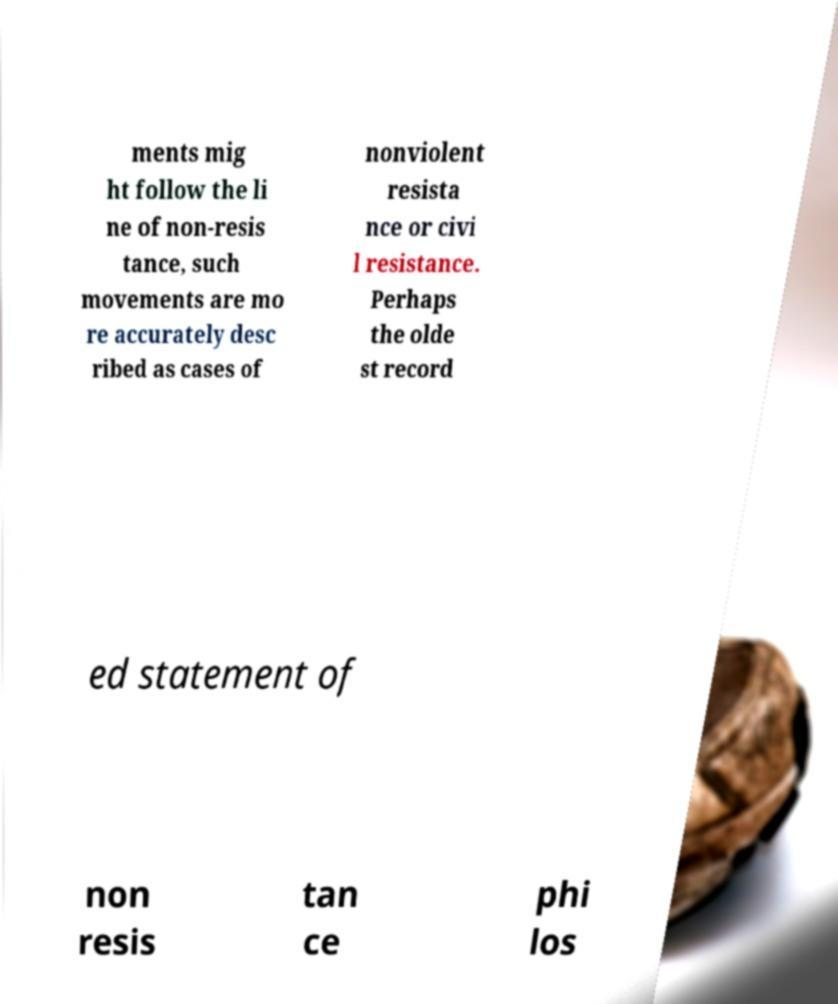For documentation purposes, I need the text within this image transcribed. Could you provide that? ments mig ht follow the li ne of non-resis tance, such movements are mo re accurately desc ribed as cases of nonviolent resista nce or civi l resistance. Perhaps the olde st record ed statement of non resis tan ce phi los 